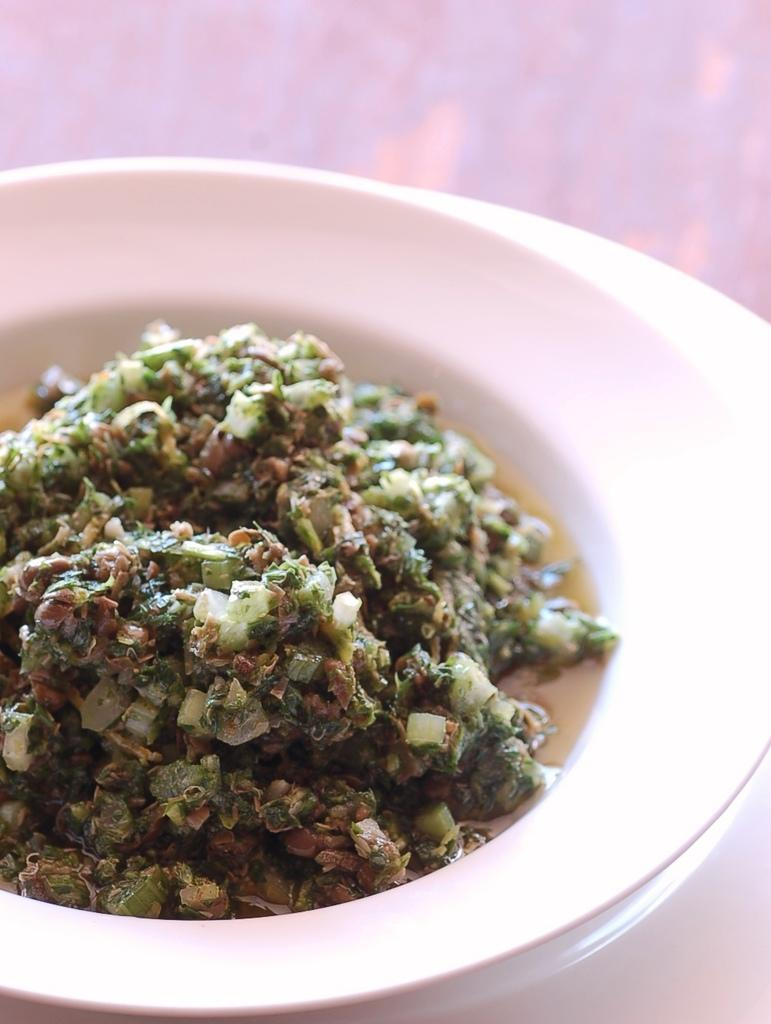What is the main subject of the image? There is a food item in the image. How is the food item presented? The food item is placed on a bowl. Where is the bowl located? The bowl is placed on a platform. What type of airplane can be seen flying over the food item in the image? There is no airplane visible in the image; it only features a food item placed on a bowl and a platform. 